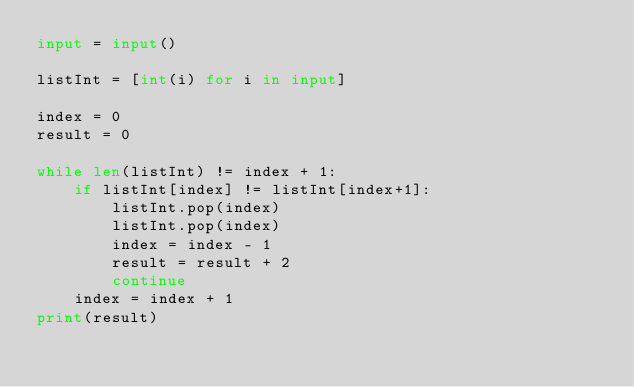<code> <loc_0><loc_0><loc_500><loc_500><_Python_>input = input()

listInt = [int(i) for i in input]

index = 0
result = 0

while len(listInt) != index + 1:
	if listInt[index] != listInt[index+1]:
		listInt.pop(index)
		listInt.pop(index)
		index = index - 1
		result = result + 2
		continue		
	index = index + 1
print(result)</code> 